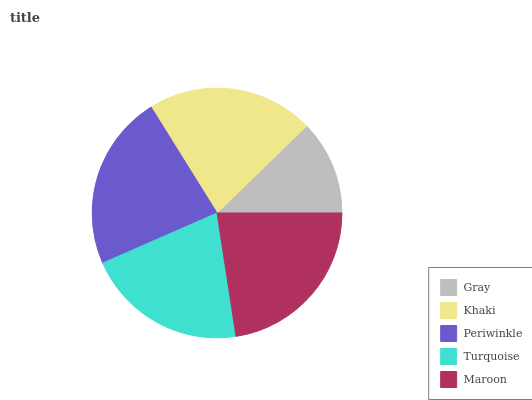Is Gray the minimum?
Answer yes or no. Yes. Is Periwinkle the maximum?
Answer yes or no. Yes. Is Khaki the minimum?
Answer yes or no. No. Is Khaki the maximum?
Answer yes or no. No. Is Khaki greater than Gray?
Answer yes or no. Yes. Is Gray less than Khaki?
Answer yes or no. Yes. Is Gray greater than Khaki?
Answer yes or no. No. Is Khaki less than Gray?
Answer yes or no. No. Is Khaki the high median?
Answer yes or no. Yes. Is Khaki the low median?
Answer yes or no. Yes. Is Maroon the high median?
Answer yes or no. No. Is Periwinkle the low median?
Answer yes or no. No. 